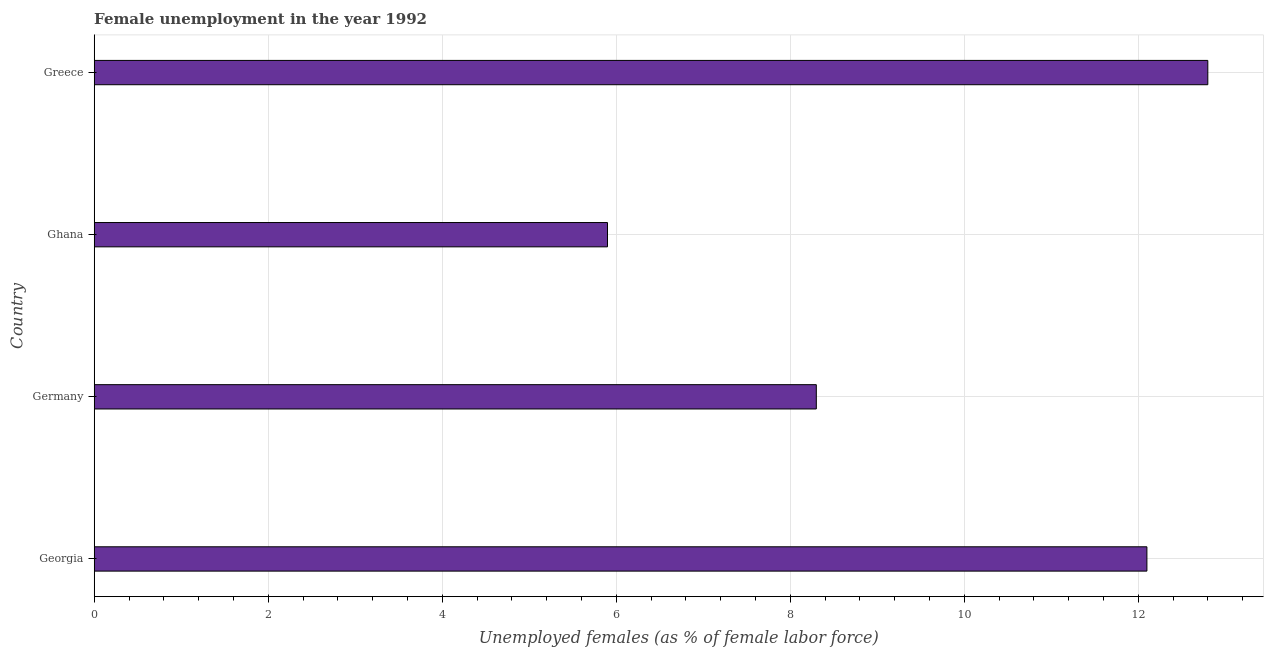Does the graph contain any zero values?
Offer a very short reply. No. Does the graph contain grids?
Your response must be concise. Yes. What is the title of the graph?
Ensure brevity in your answer.  Female unemployment in the year 1992. What is the label or title of the X-axis?
Ensure brevity in your answer.  Unemployed females (as % of female labor force). What is the unemployed females population in Georgia?
Your response must be concise. 12.1. Across all countries, what is the maximum unemployed females population?
Offer a very short reply. 12.8. Across all countries, what is the minimum unemployed females population?
Your response must be concise. 5.9. In which country was the unemployed females population minimum?
Your answer should be very brief. Ghana. What is the sum of the unemployed females population?
Offer a very short reply. 39.1. What is the average unemployed females population per country?
Your response must be concise. 9.78. What is the median unemployed females population?
Your answer should be compact. 10.2. What is the ratio of the unemployed females population in Germany to that in Greece?
Provide a succinct answer. 0.65. What is the difference between the highest and the second highest unemployed females population?
Your answer should be very brief. 0.7. What is the difference between the highest and the lowest unemployed females population?
Your response must be concise. 6.9. In how many countries, is the unemployed females population greater than the average unemployed females population taken over all countries?
Your response must be concise. 2. How many bars are there?
Your answer should be very brief. 4. Are all the bars in the graph horizontal?
Provide a short and direct response. Yes. What is the difference between two consecutive major ticks on the X-axis?
Your answer should be compact. 2. Are the values on the major ticks of X-axis written in scientific E-notation?
Provide a short and direct response. No. What is the Unemployed females (as % of female labor force) in Georgia?
Ensure brevity in your answer.  12.1. What is the Unemployed females (as % of female labor force) in Germany?
Offer a terse response. 8.3. What is the Unemployed females (as % of female labor force) in Ghana?
Your answer should be compact. 5.9. What is the Unemployed females (as % of female labor force) in Greece?
Your answer should be very brief. 12.8. What is the difference between the Unemployed females (as % of female labor force) in Georgia and Ghana?
Offer a very short reply. 6.2. What is the difference between the Unemployed females (as % of female labor force) in Georgia and Greece?
Provide a short and direct response. -0.7. What is the difference between the Unemployed females (as % of female labor force) in Germany and Ghana?
Your response must be concise. 2.4. What is the difference between the Unemployed females (as % of female labor force) in Ghana and Greece?
Ensure brevity in your answer.  -6.9. What is the ratio of the Unemployed females (as % of female labor force) in Georgia to that in Germany?
Ensure brevity in your answer.  1.46. What is the ratio of the Unemployed females (as % of female labor force) in Georgia to that in Ghana?
Give a very brief answer. 2.05. What is the ratio of the Unemployed females (as % of female labor force) in Georgia to that in Greece?
Your response must be concise. 0.94. What is the ratio of the Unemployed females (as % of female labor force) in Germany to that in Ghana?
Offer a very short reply. 1.41. What is the ratio of the Unemployed females (as % of female labor force) in Germany to that in Greece?
Your response must be concise. 0.65. What is the ratio of the Unemployed females (as % of female labor force) in Ghana to that in Greece?
Ensure brevity in your answer.  0.46. 